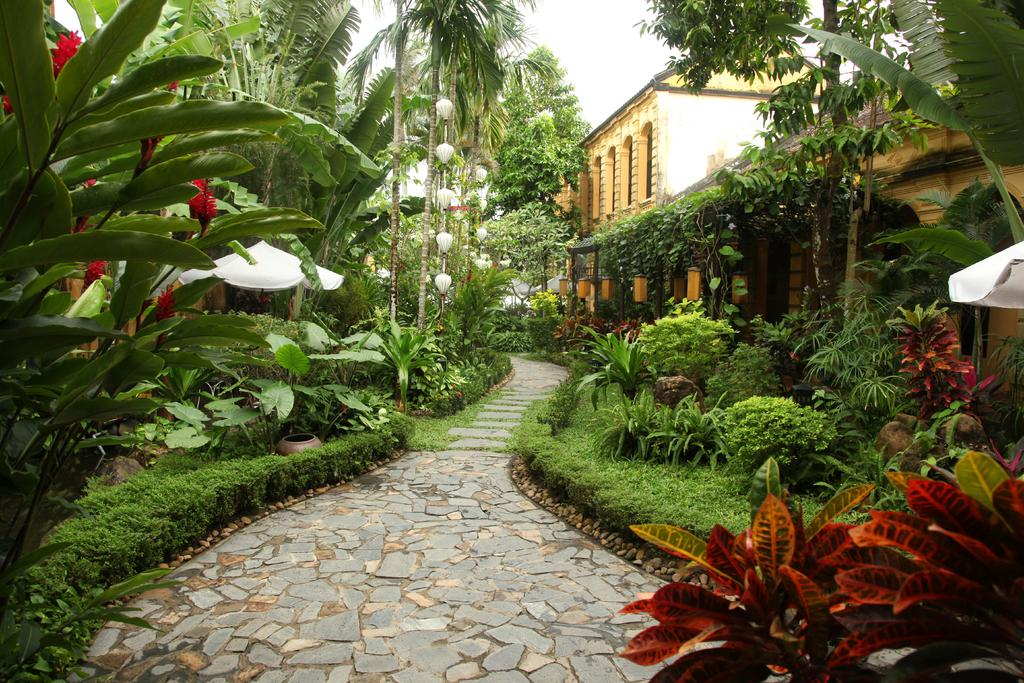What type of vegetation can be seen on both sides of the image? There are trees and plants on both the right and left sides of the image. What is located in the middle of the trees and plants? There is a path in the middle of the trees and plants. What structure can be seen on the right side of the image? There is a building on the right side of the image. What is visible in the background of the image? The sky is visible in the background of the image. Can you tell me how many pencils are lying on the path in the image? There are no pencils present in the image; it features trees, plants, a path, a building, and the sky. What type of amusement park can be seen in the background of the image? There is no amusement park visible in the image; it features trees, plants, a path, a building, and the sky. 